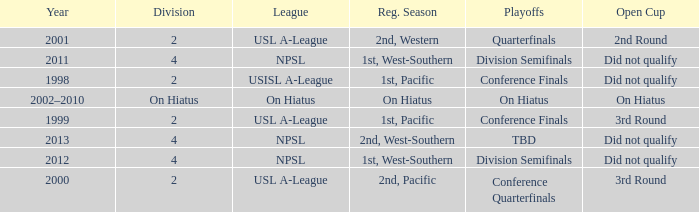When did the usl a-league have conference finals? 1999.0. 